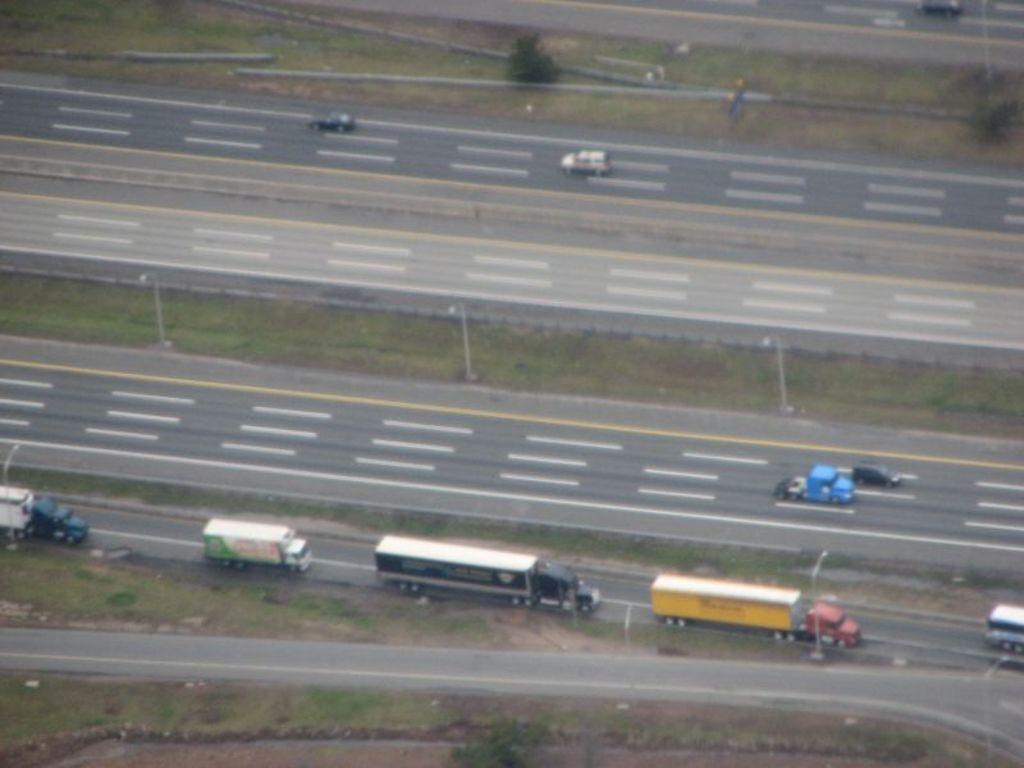Could you give a brief overview of what you see in this image? In this image I can see few vehicles on the road and I can also see few light poles. Background I can see few trees in green color. 